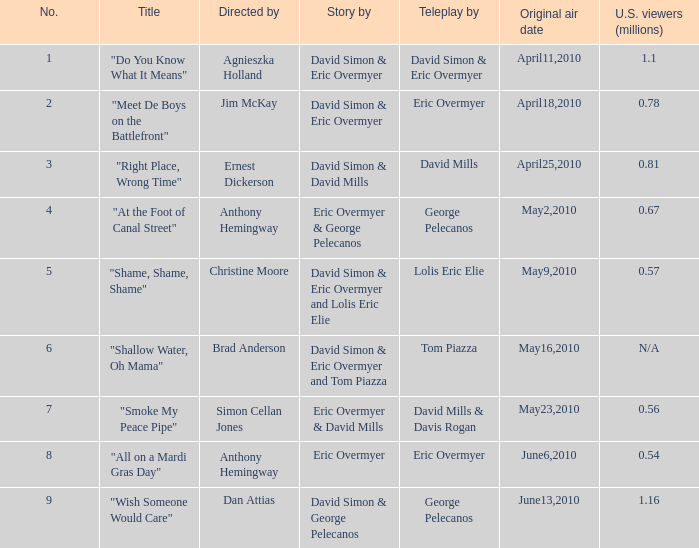Name the most number 9.0. 